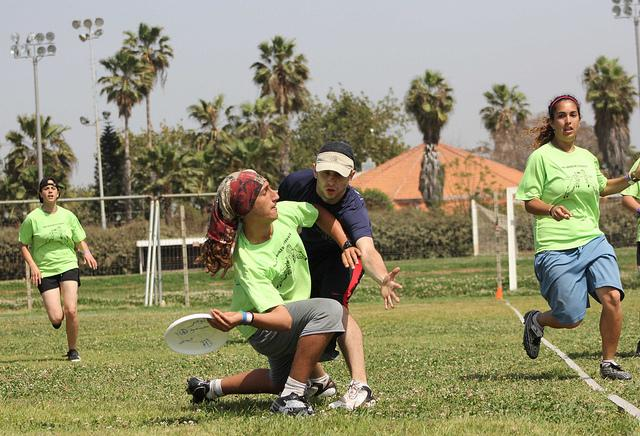The players are wearing the same shirts because they play in a what? team 